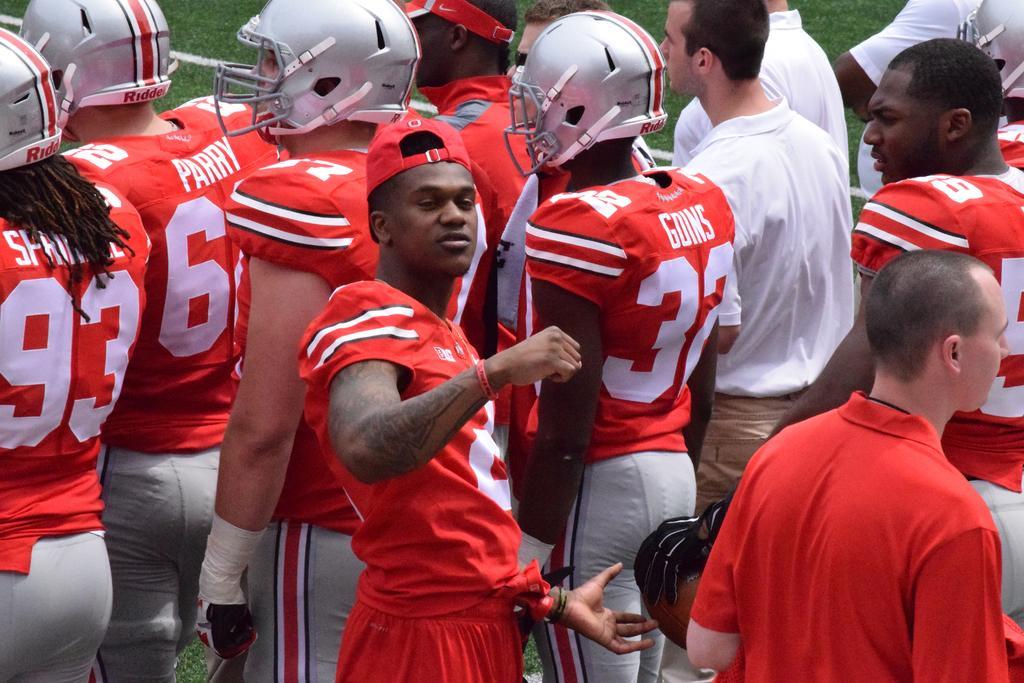Could you give a brief overview of what you see in this image? By seeing this image we can say that some group of people are there, some of them are wearing red color dress and some of the them are wearing white color T-shirt. I think they all are sports players. 